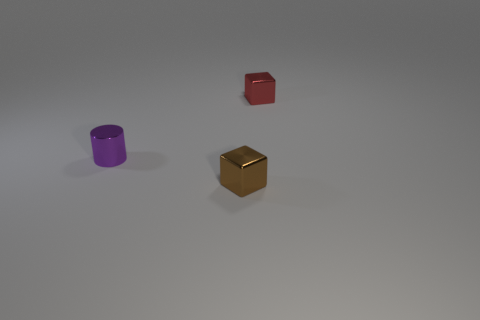Add 2 purple metal things. How many objects exist? 5 Subtract all blocks. How many objects are left? 1 Subtract 0 gray cylinders. How many objects are left? 3 Subtract all big yellow rubber blocks. Subtract all brown cubes. How many objects are left? 2 Add 1 purple metallic cylinders. How many purple metallic cylinders are left? 2 Add 2 big purple objects. How many big purple objects exist? 2 